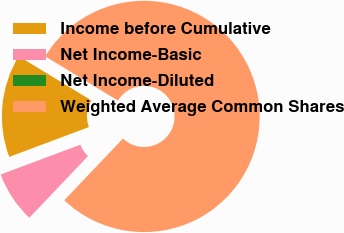Convert chart to OTSL. <chart><loc_0><loc_0><loc_500><loc_500><pie_chart><fcel>Income before Cumulative<fcel>Net Income-Basic<fcel>Net Income-Diluted<fcel>Weighted Average Common Shares<nl><fcel>14.4%<fcel>7.2%<fcel>0.0%<fcel>78.41%<nl></chart> 